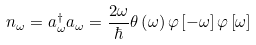Convert formula to latex. <formula><loc_0><loc_0><loc_500><loc_500>n _ { \omega } = a _ { \omega } ^ { \dagger } a _ { \omega } = \frac { 2 \omega } \hbar { \theta } \left ( \omega \right ) \varphi \left [ - \omega \right ] \varphi \left [ \omega \right ]</formula> 